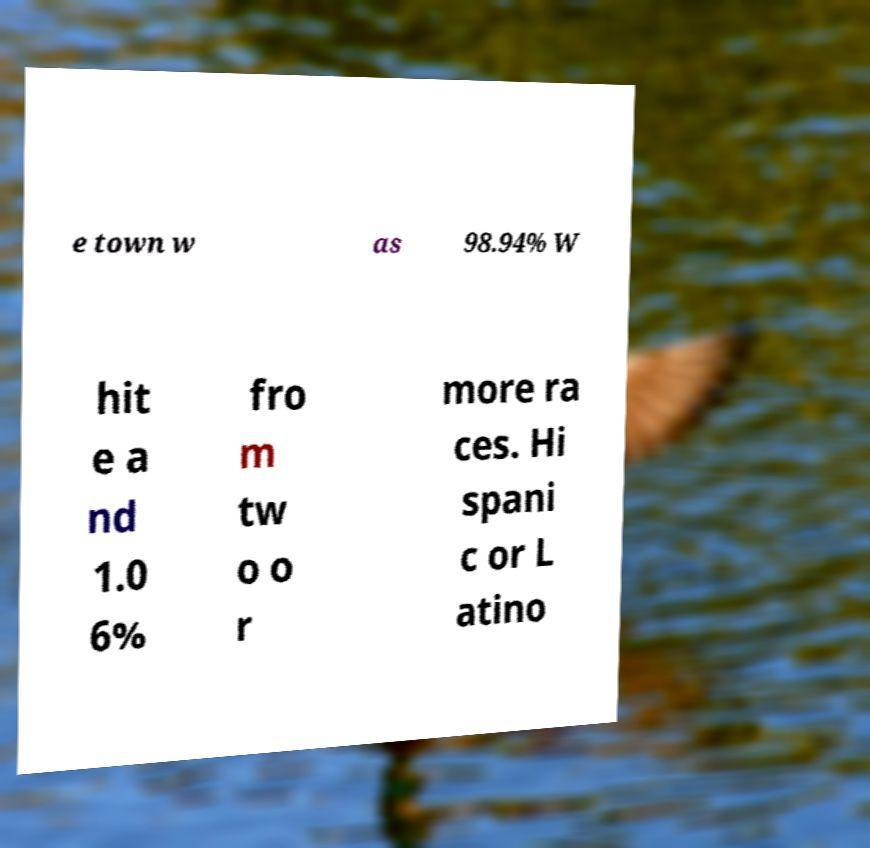Please identify and transcribe the text found in this image. e town w as 98.94% W hit e a nd 1.0 6% fro m tw o o r more ra ces. Hi spani c or L atino 